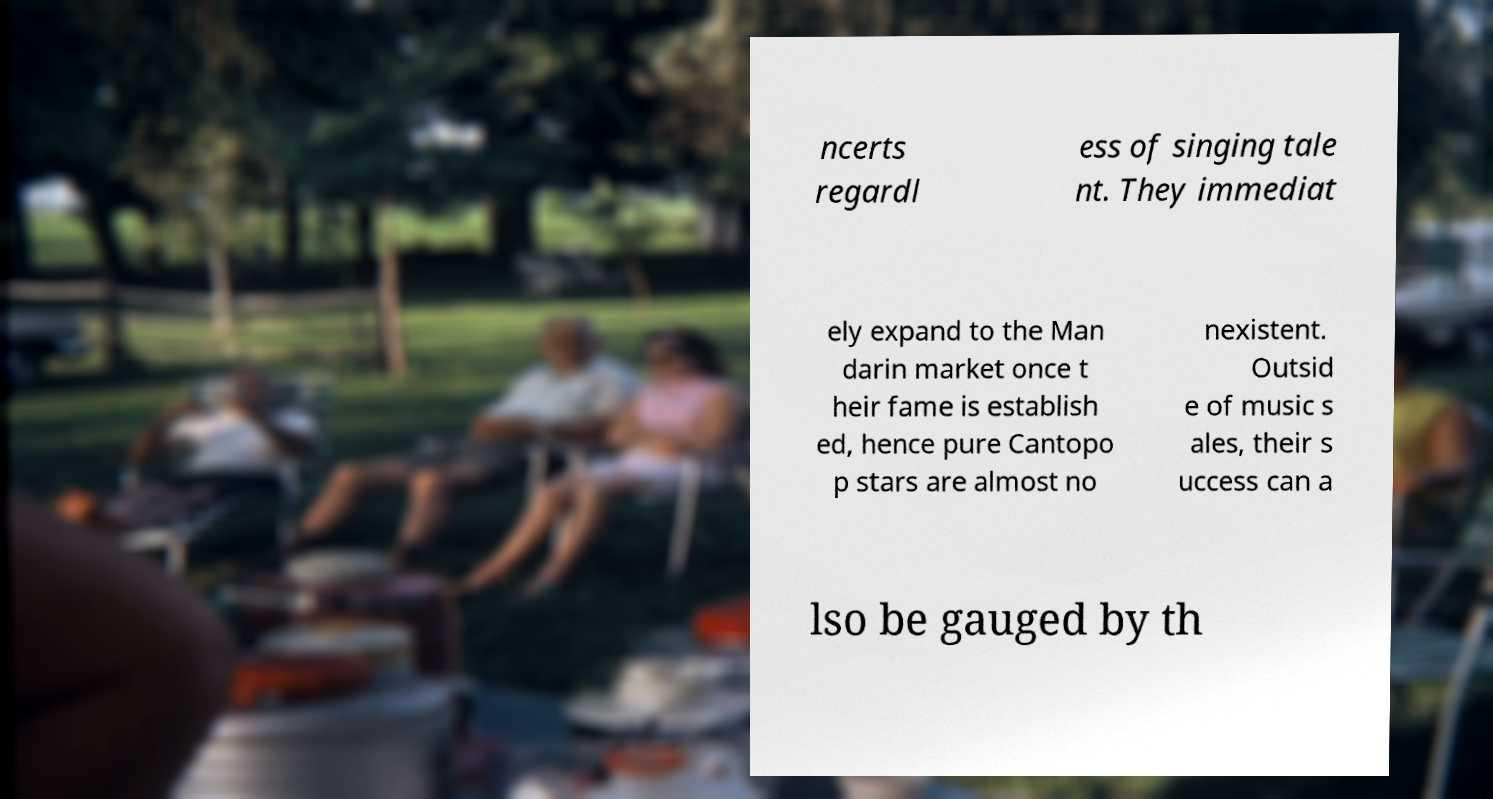What messages or text are displayed in this image? I need them in a readable, typed format. ncerts regardl ess of singing tale nt. They immediat ely expand to the Man darin market once t heir fame is establish ed, hence pure Cantopo p stars are almost no nexistent. Outsid e of music s ales, their s uccess can a lso be gauged by th 